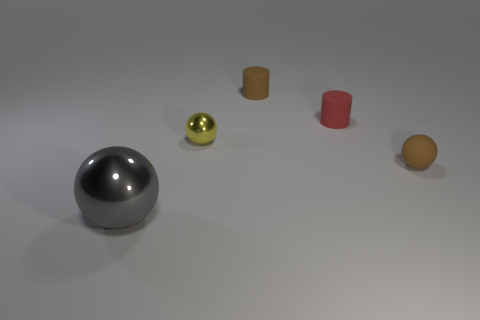Add 3 tiny brown cylinders. How many objects exist? 8 Subtract all balls. How many objects are left? 2 Add 4 metallic things. How many metallic things are left? 6 Add 3 gray spheres. How many gray spheres exist? 4 Subtract 0 green blocks. How many objects are left? 5 Subtract all brown rubber cylinders. Subtract all tiny brown rubber objects. How many objects are left? 2 